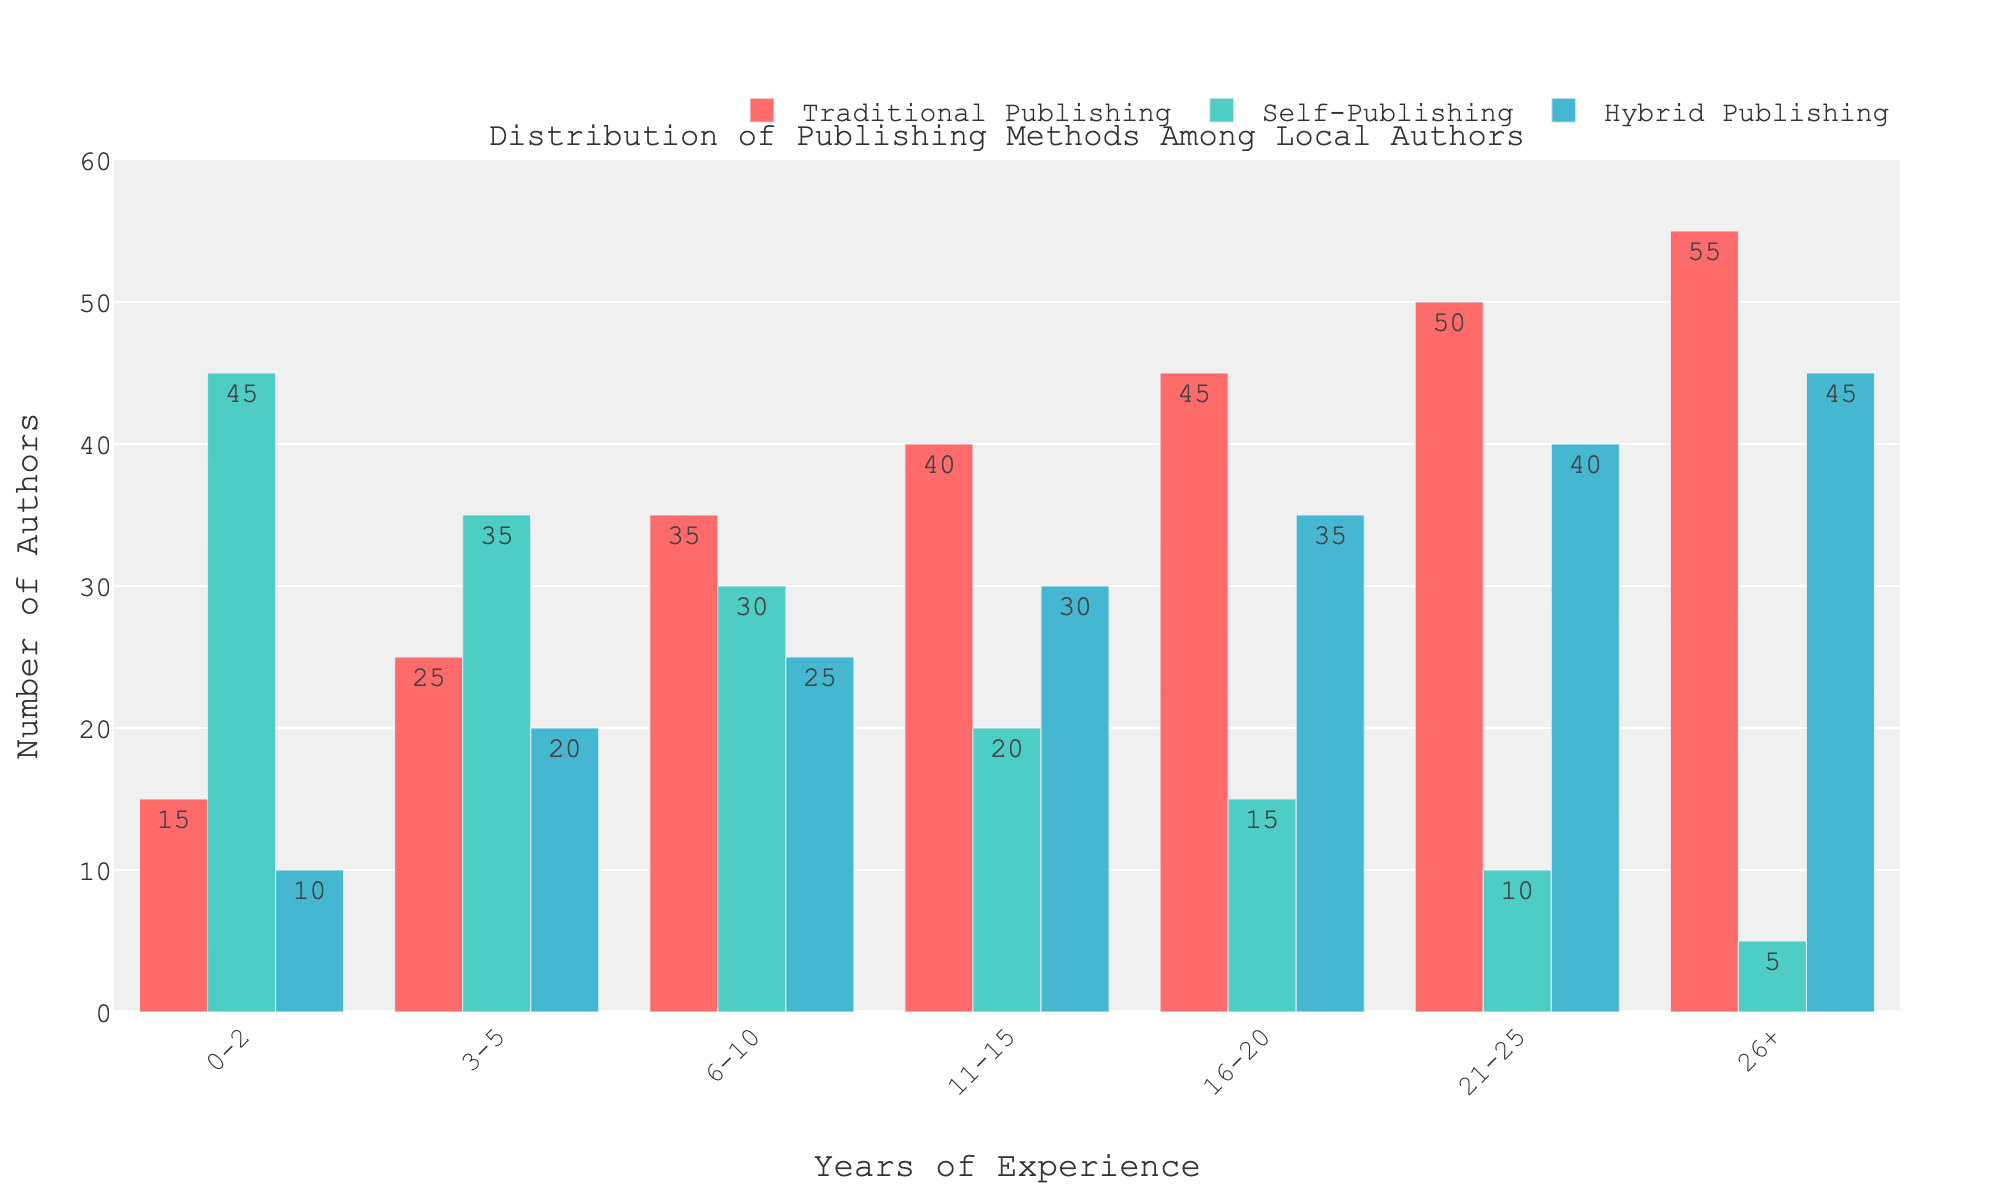What is the total number of authors with 3-5 years of experience? To find the total number of authors with 3-5 years of experience, add the values for Traditional Publishing, Self-Publishing, and Hybrid Publishing for that category: 25 (Traditional Publishing) + 35 (Self-Publishing) + 20 (Hybrid Publishing) = 80.
Answer: 80 Which publishing method is the most popular among authors with 11-15 years of experience? Look at the bar heights for authors with 11-15 years of experience. Traditional Publishing has 40 authors, Self-Publishing has 20 authors, and Hybrid Publishing has 30 authors. 40 is the highest.
Answer: Traditional Publishing How many more authors with 21-25 years of experience choose Traditional Publishing over Self-Publishing? Subtract the number of authors using Self-Publishing from those using Traditional Publishing for the 21-25 years of experience category: 50 (Traditional Publishing) - 10 (Self-Publishing) = 40.
Answer: 40 Is the number of self-published authors generally increasing or decreasing with years of experience? Observe the trend of Self-Publishing across different years of experience. The bar heights show a decreasing pattern: 45, 35, 30, 20, 15, 10, 5.
Answer: Decreasing What’s the difference in the number of authors using Hybrid Publishing between the least and most experienced groups? Identify the Hybrid Publishing numbers for 0-2 years (10 authors) and 26+ years (45 authors). Subtract the smaller value from the larger one: 45 - 10 = 35.
Answer: 35 What is the average number of authors using Traditional Publishing across all experience groups? Sum the Traditional Publishing numbers across all experience groups and divide by the number of groups: (15 + 25 + 35 + 40 + 45 + 50 + 55) / 7 = 265 / 7 ≈ 37.86.
Answer: 37.86 How does the number of authors using Hybrid Publishing compare to those using Traditional Publishing in the 6-10 years category? Look at the bar heights for Hybrid and Traditional Publishing for the 6-10 years of experience category. Hybrid Publishing has 25 authors, whereas Traditional Publishing has 35 authors. 35 is greater than 25.
Answer: Traditional Publishing has more What is the sum of authors in the 16-20 years of experience group using either Traditional or Hybrid Publishing? Add the numbers for Traditional and Hybrid Publishing for the 16-20 years category: 45 (Traditional) + 35 (Hybrid) = 80.
Answer: 80 